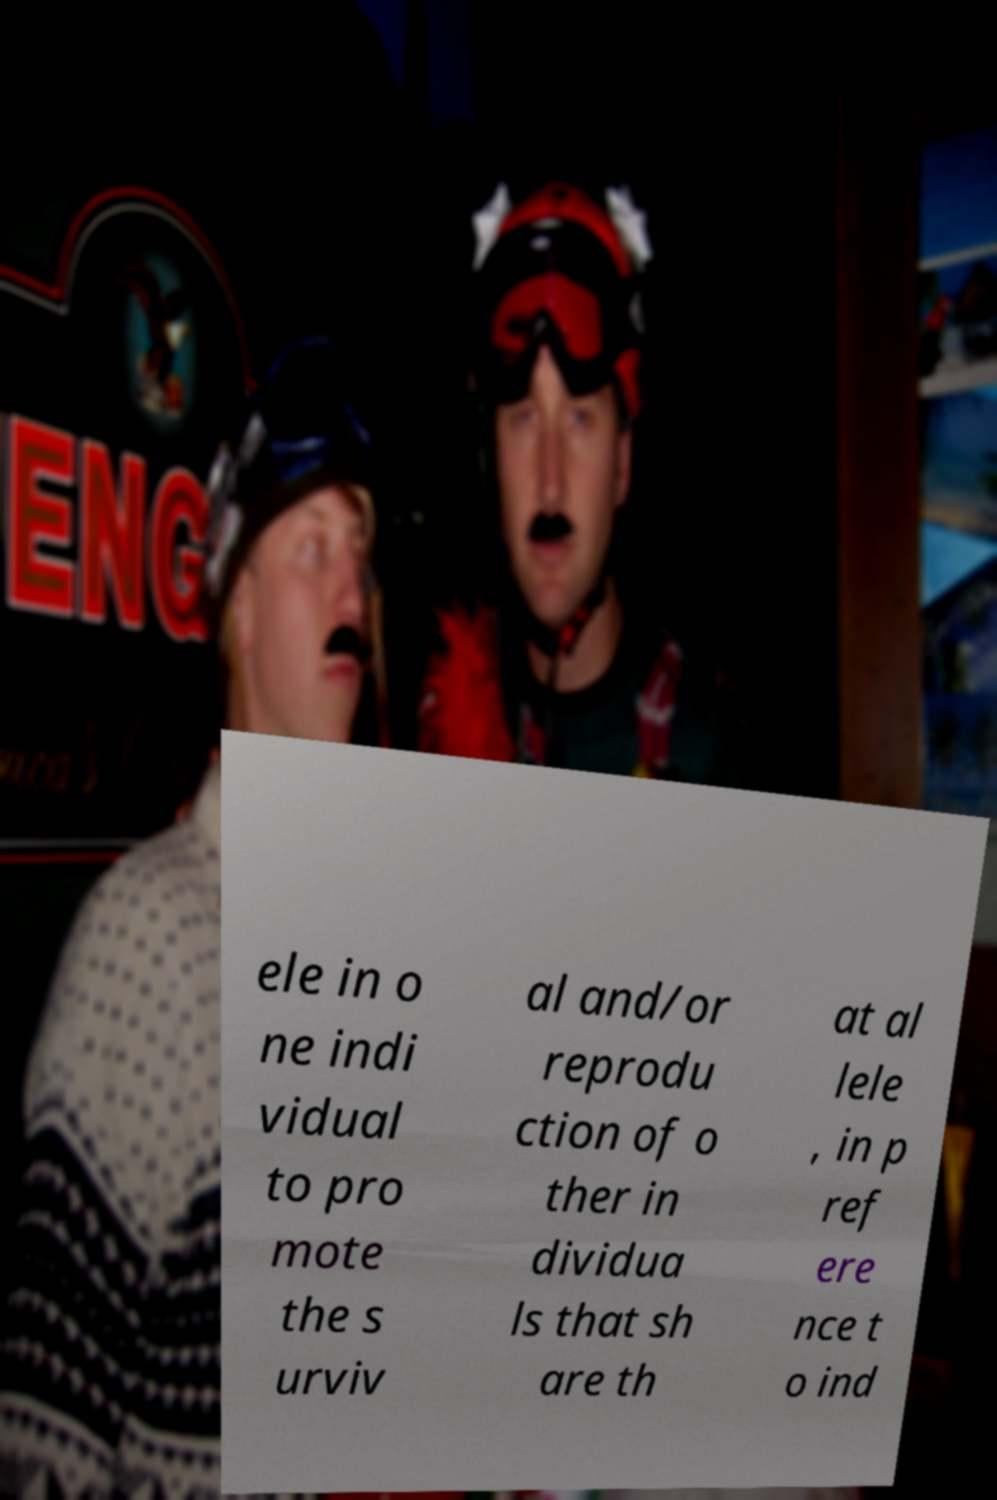Could you assist in decoding the text presented in this image and type it out clearly? ele in o ne indi vidual to pro mote the s urviv al and/or reprodu ction of o ther in dividua ls that sh are th at al lele , in p ref ere nce t o ind 